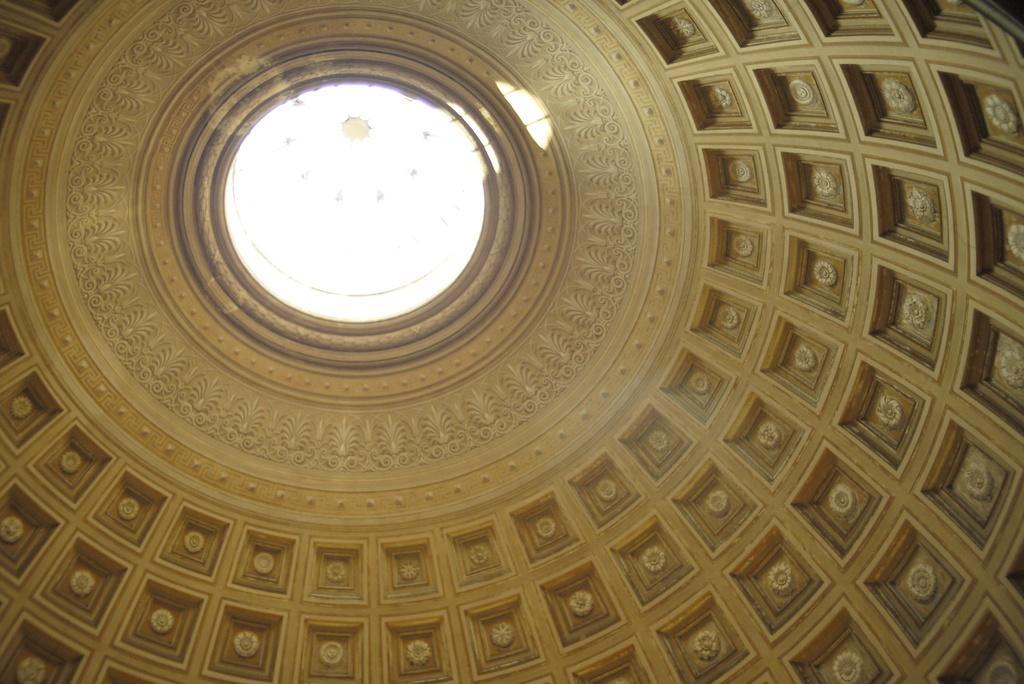Could you give a brief overview of what you see in this image? In this image we can see the dome of the Vatican Museum. 